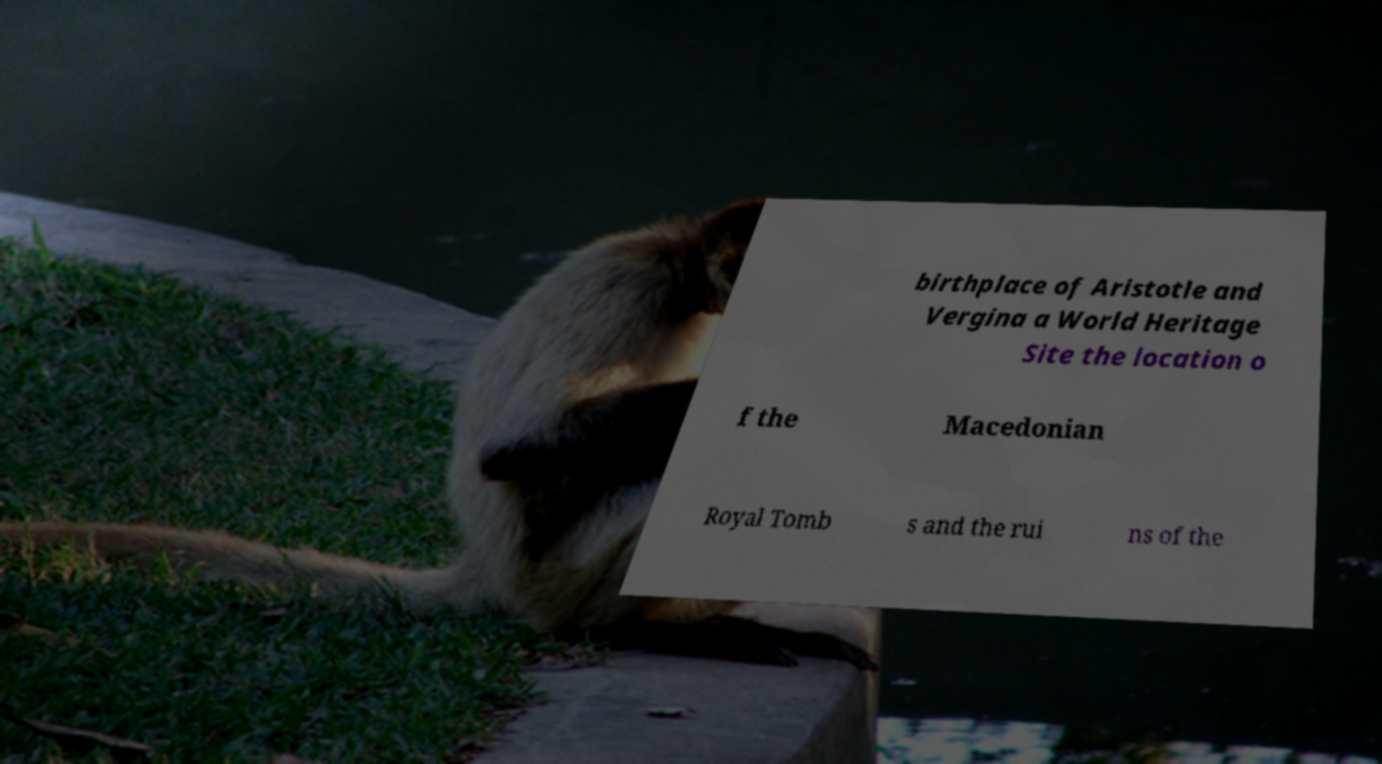Can you read and provide the text displayed in the image?This photo seems to have some interesting text. Can you extract and type it out for me? birthplace of Aristotle and Vergina a World Heritage Site the location o f the Macedonian Royal Tomb s and the rui ns of the 